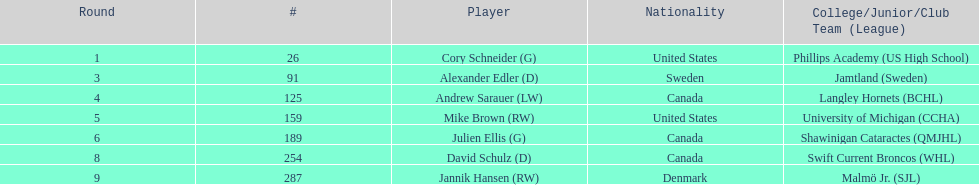How many players from canada are mentioned? 3. 